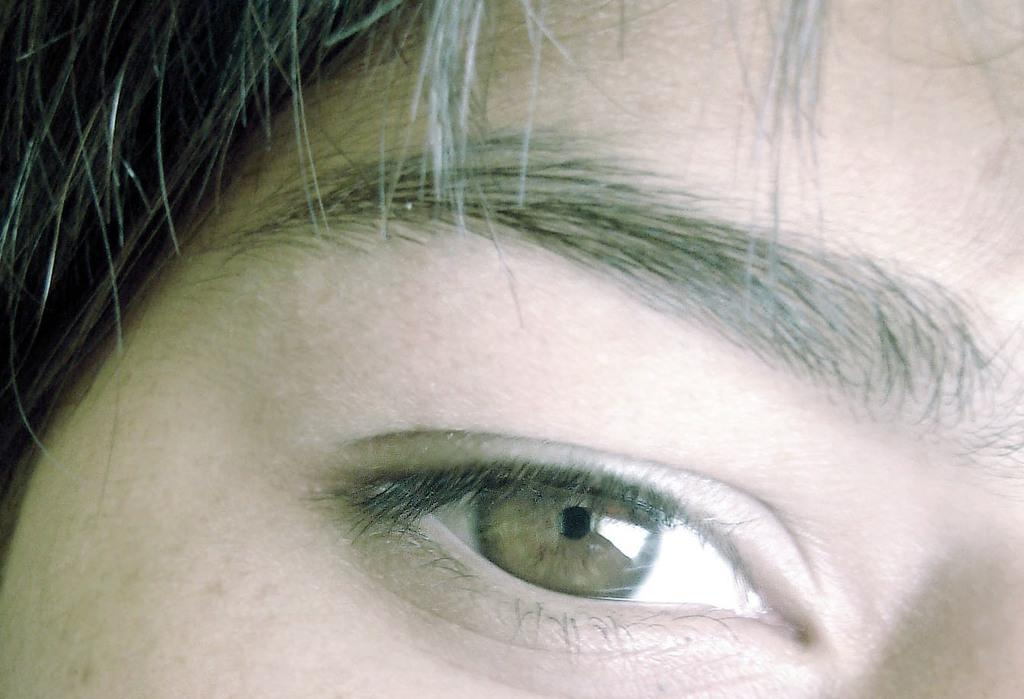What is the main subject of the image? The main subject of the image is an eye. What is located above the eye in the image? There is an eyebrow in the image. Is there a veil covering the eye in the image? No, there is no veil present in the image. What type of property is depicted in the image? The image does not depict any property; it features an eye and an eyebrow. 